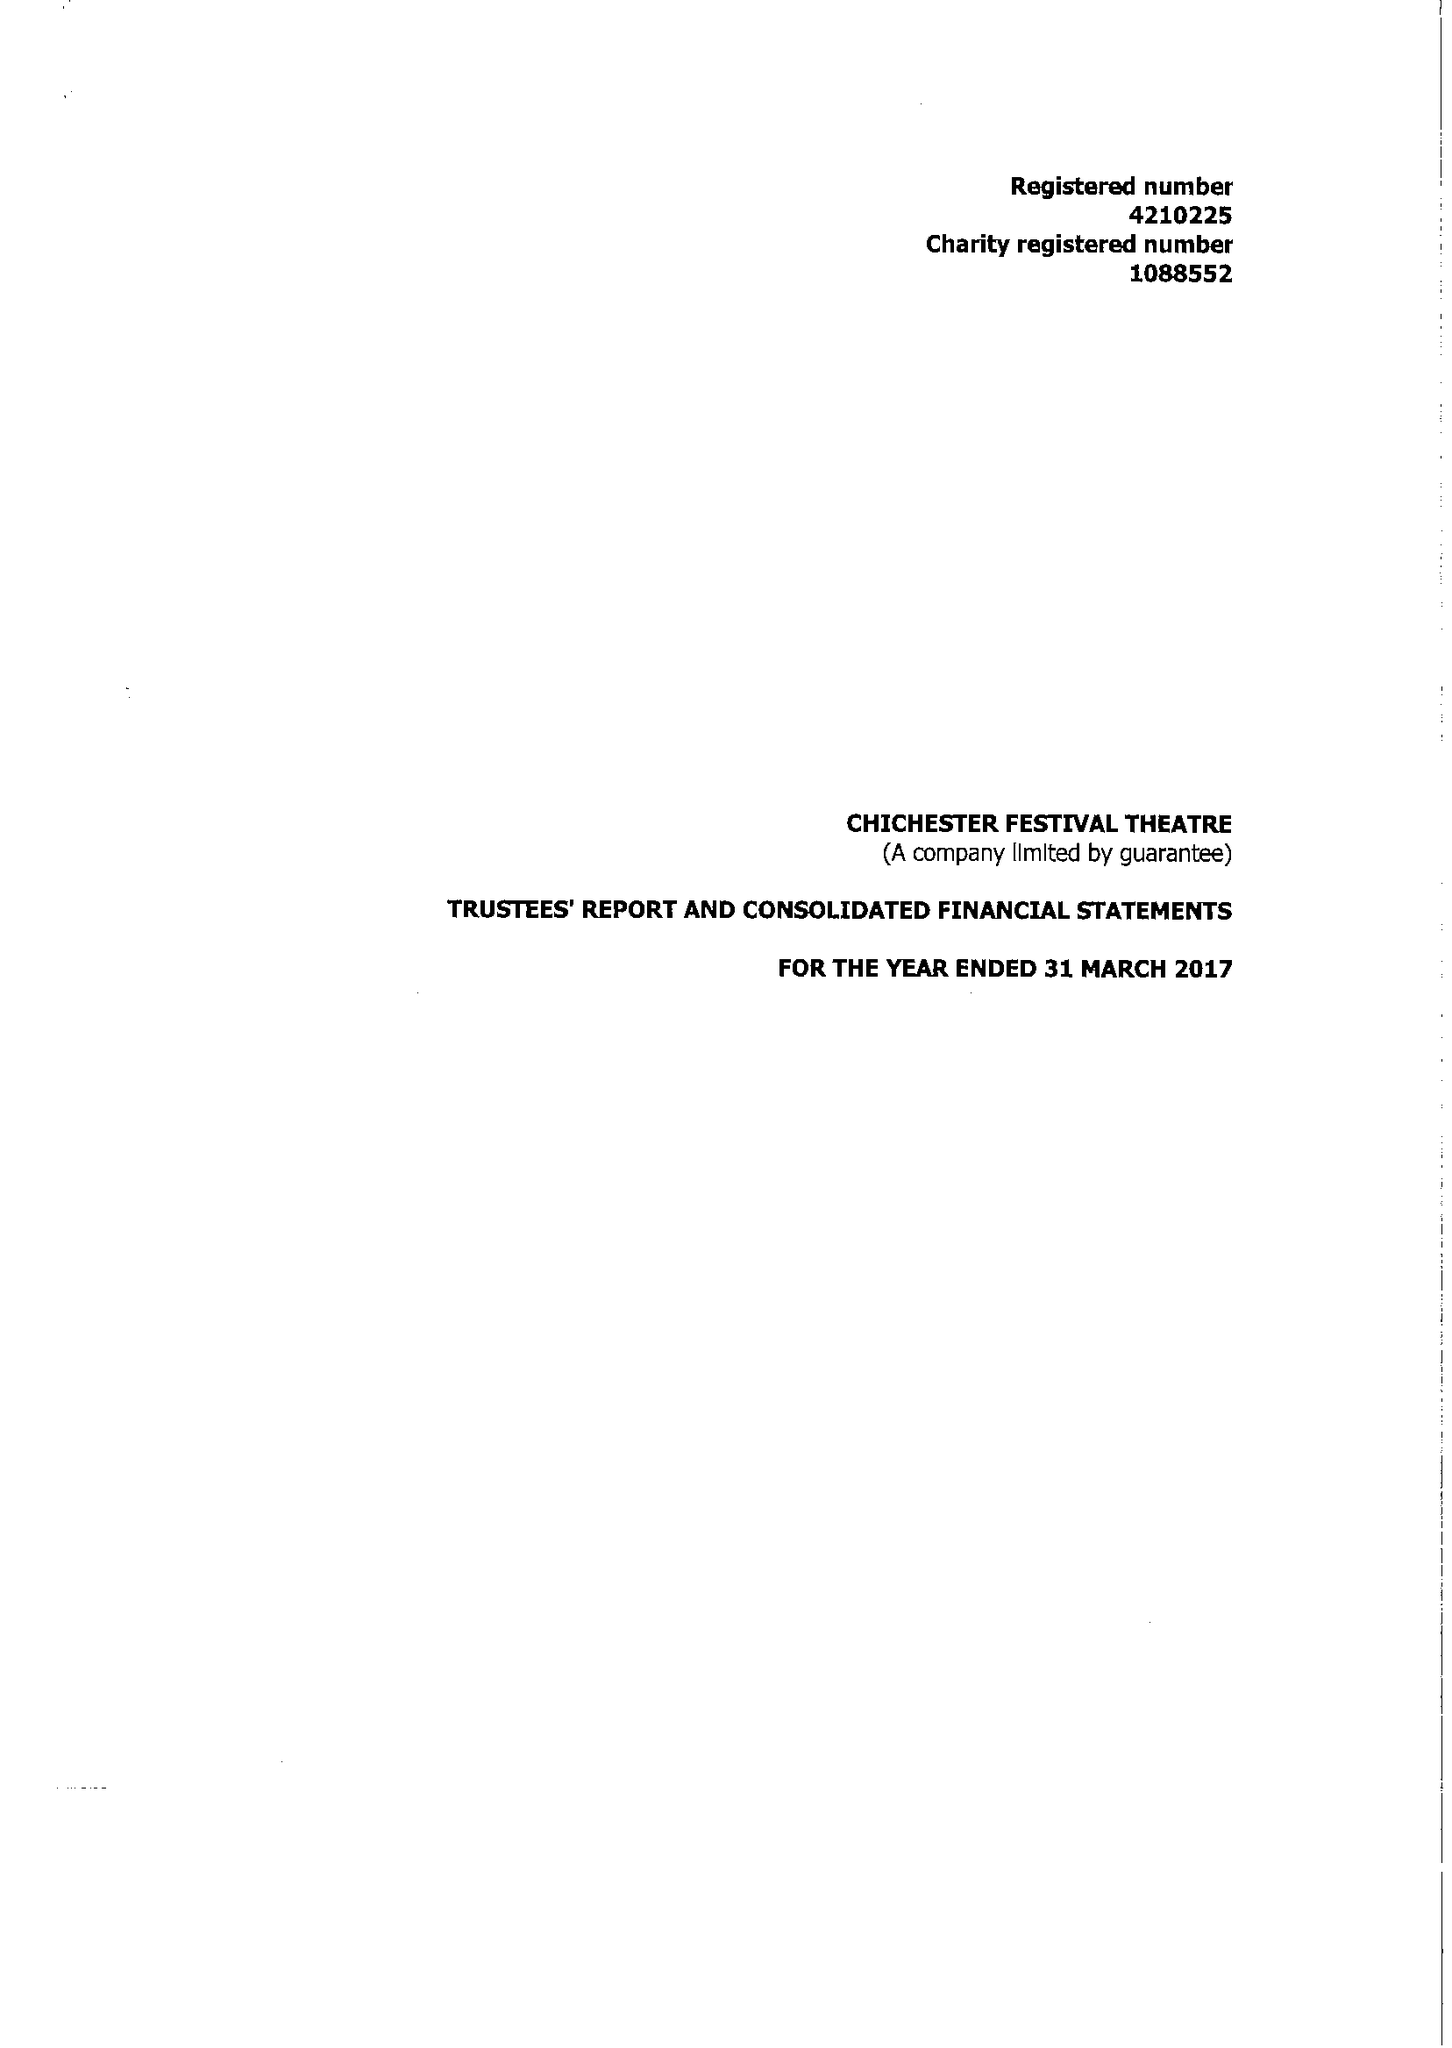What is the value for the income_annually_in_british_pounds?
Answer the question using a single word or phrase. 17165300.00 